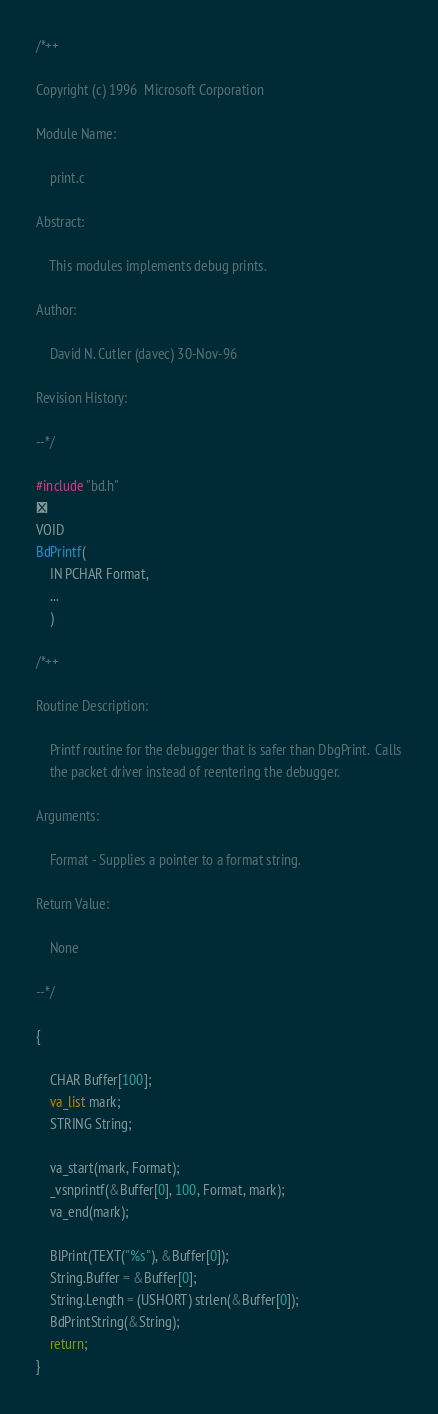<code> <loc_0><loc_0><loc_500><loc_500><_C_>/*++

Copyright (c) 1996  Microsoft Corporation

Module Name:

    print.c

Abstract:

    This modules implements debug prints.

Author:

    David N. Cutler (davec) 30-Nov-96

Revision History:

--*/

#include "bd.h"

VOID
BdPrintf(
    IN PCHAR Format,
    ...
    )

/*++

Routine Description:

    Printf routine for the debugger that is safer than DbgPrint.  Calls
    the packet driver instead of reentering the debugger.

Arguments:

    Format - Supplies a pointer to a format string.

Return Value:

    None

--*/

{

    CHAR Buffer[100];
    va_list mark;
    STRING String;

    va_start(mark, Format);
    _vsnprintf(&Buffer[0], 100, Format, mark);
    va_end(mark);

    BlPrint(TEXT("%s"), &Buffer[0]);
    String.Buffer = &Buffer[0];
    String.Length = (USHORT) strlen(&Buffer[0]);
    BdPrintString(&String);
    return;
}
</code> 